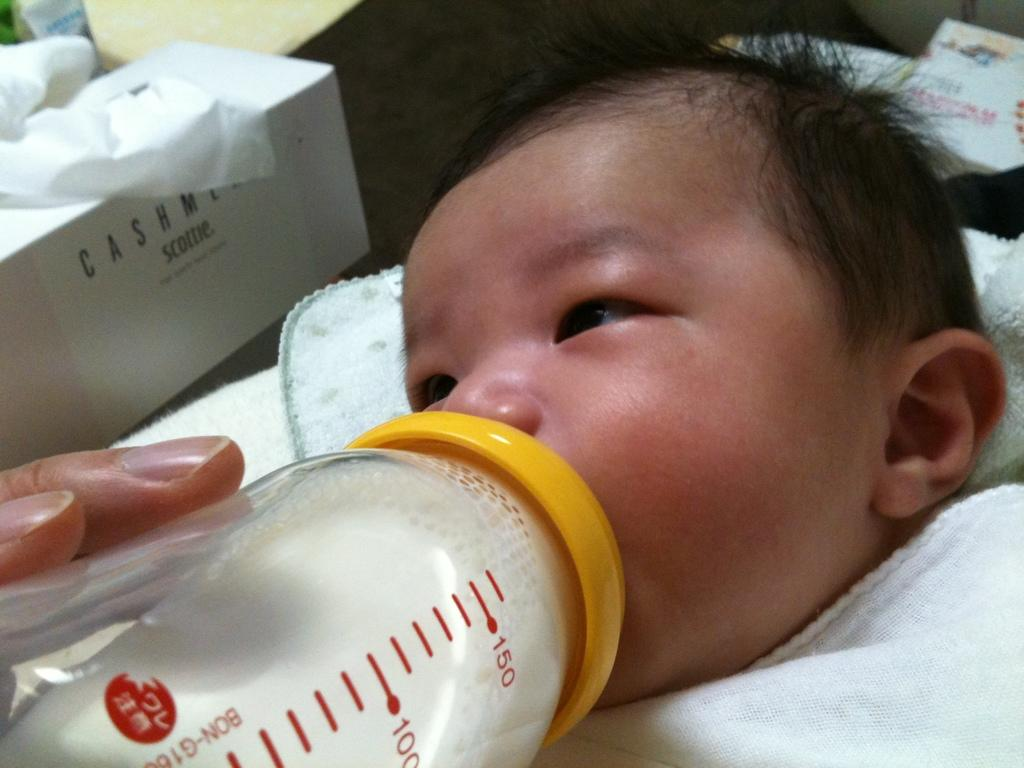What is the baby in the image doing? The baby is drinking milk from a bottle. How is the baby dressed or covered in the image? The baby has a cloth wrapped around it. What object is on the left side of the image? There is a tissue paper box on the left side of the image. Whose hand is visible in the image? The hand of a person is visible in the image. What type of lunch is the baby eating in the image? The baby is not eating lunch in the image; they are drinking milk from a bottle. Is there a whip visible in the image? No, there is no whip present in the image. 